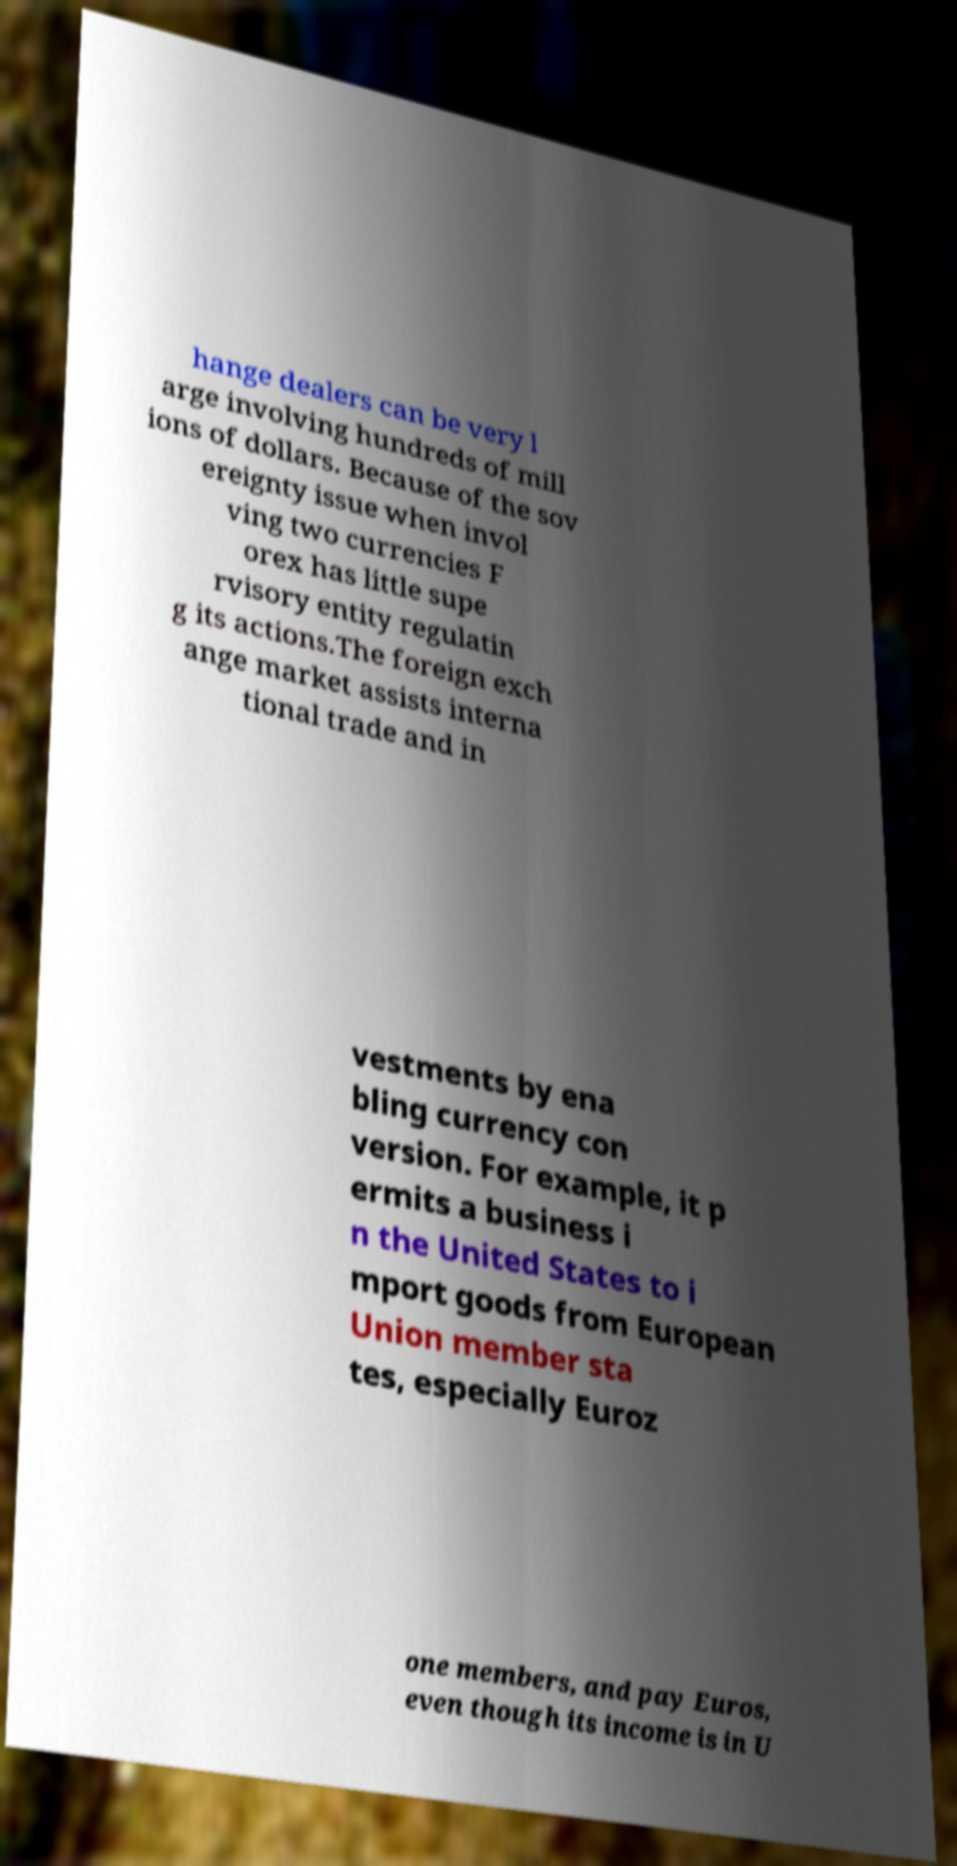Please identify and transcribe the text found in this image. hange dealers can be very l arge involving hundreds of mill ions of dollars. Because of the sov ereignty issue when invol ving two currencies F orex has little supe rvisory entity regulatin g its actions.The foreign exch ange market assists interna tional trade and in vestments by ena bling currency con version. For example, it p ermits a business i n the United States to i mport goods from European Union member sta tes, especially Euroz one members, and pay Euros, even though its income is in U 